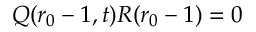Convert formula to latex. <formula><loc_0><loc_0><loc_500><loc_500>Q ( r _ { 0 } - 1 , t ) R ( r _ { 0 } - 1 ) = 0</formula> 